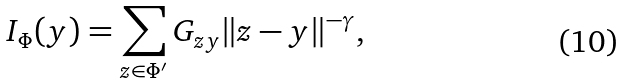Convert formula to latex. <formula><loc_0><loc_0><loc_500><loc_500>I _ { \Phi } ( y ) = \sum _ { z \in \Phi ^ { \prime } } G _ { z y } \| z - y \| ^ { - \gamma } ,</formula> 